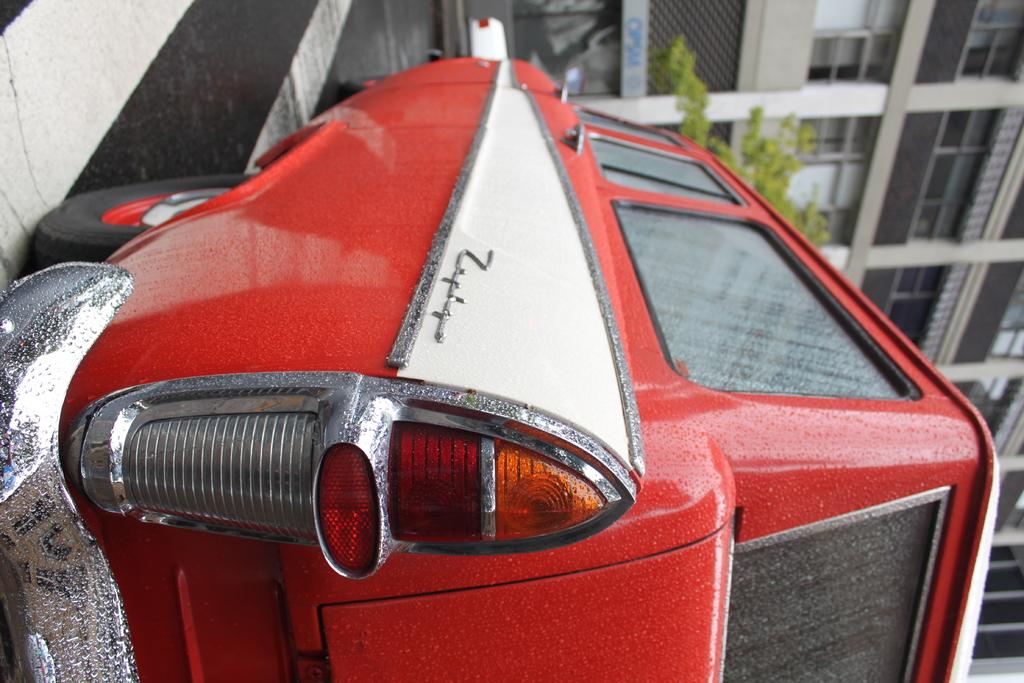What type of vehicle is in the image? There is a red color vehicle in the image. Where is the vehicle located in the image? The vehicle is in the front of the image. What can be seen in the background of the image? There is a building in the background of the image. What is in the middle of the image? There is a tree in the middle of the image. How does the coach perform addition in the image? There is no coach present in the image, and therefore no such activity can be observed. 